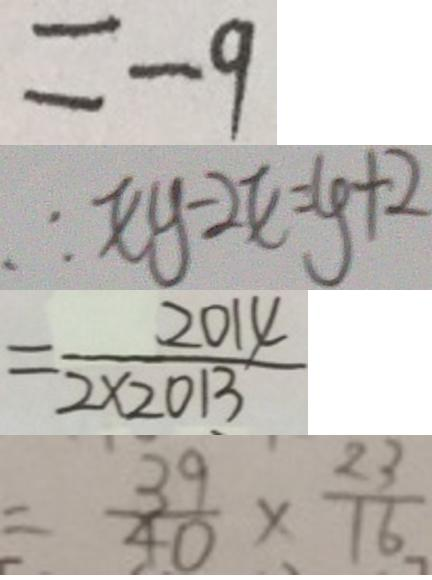<formula> <loc_0><loc_0><loc_500><loc_500>= - 9 
 \therefore x y - 2 x = y + 2 
 = \frac { 2 0 1 4 } { 2 \times 2 0 1 3 } 
 = \frac { 3 9 } { 4 0 } \times \frac { 2 3 } { 1 6 }</formula> 